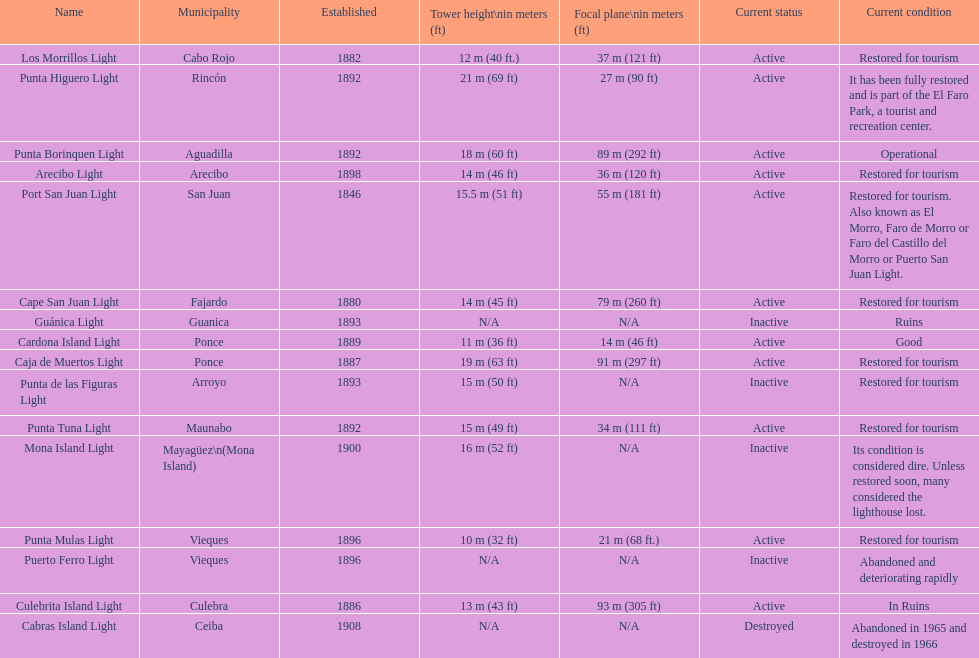Were any towers established before the year 1800? No. 